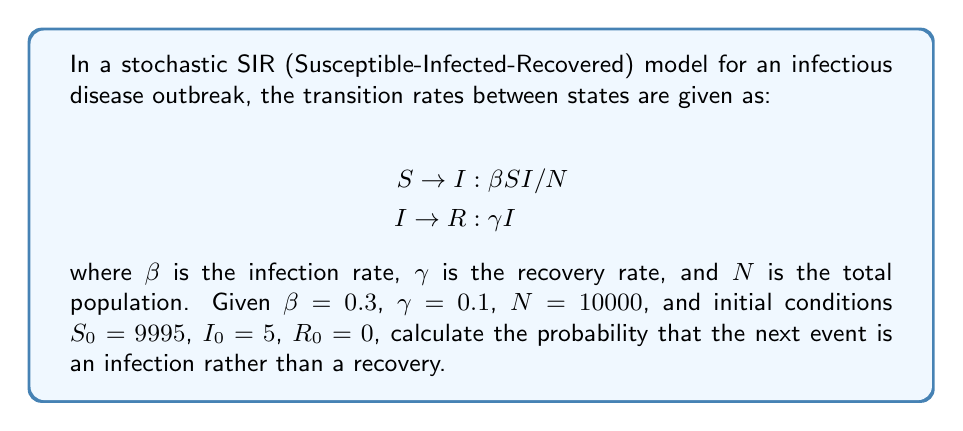Help me with this question. To solve this problem, we need to follow these steps:

1) In a stochastic SIR model, the next event is determined by the rates of possible transitions. We have two possible events:
   - Infection (S to I)
   - Recovery (I to R)

2) The rate of infection is given by:
   $$r_{infection} = \beta SI/N = 0.3 \cdot 9995 \cdot 5 / 10000 = 1.49925$$

3) The rate of recovery is given by:
   $$r_{recovery} = \gamma I = 0.1 \cdot 5 = 0.5$$

4) The total rate is the sum of these two rates:
   $$r_{total} = r_{infection} + r_{recovery} = 1.49925 + 0.5 = 1.99925$$

5) The probability of the next event being an infection is the ratio of the infection rate to the total rate:
   $$P(infection) = \frac{r_{infection}}{r_{total}} = \frac{1.49925}{1.99925} \approx 0.7499$$

Therefore, the probability that the next event is an infection is approximately 0.7499 or about 75%.
Answer: 0.7499 